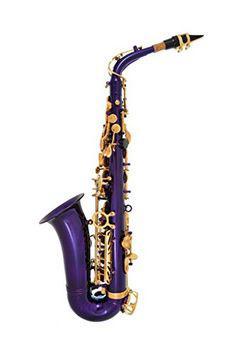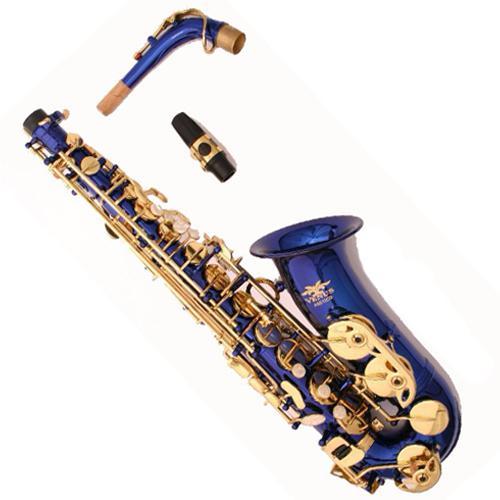The first image is the image on the left, the second image is the image on the right. Examine the images to the left and right. Is the description "Both images contain a saxophone that is a blue or purple non-traditional color and all saxophones on the right have the bell facing upwards." accurate? Answer yes or no. Yes. The first image is the image on the left, the second image is the image on the right. For the images displayed, is the sentence "Both of the saxophone bodies share the same rich color, and it is not a traditional metallic (silver or gold) color." factually correct? Answer yes or no. Yes. 